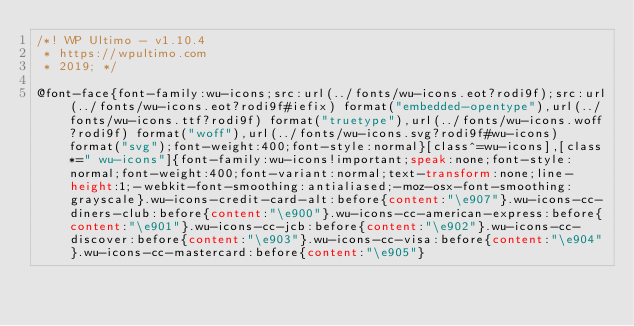Convert code to text. <code><loc_0><loc_0><loc_500><loc_500><_CSS_>/*! WP Ultimo - v1.10.4
 * https://wpultimo.com
 * 2019; */

@font-face{font-family:wu-icons;src:url(../fonts/wu-icons.eot?rodi9f);src:url(../fonts/wu-icons.eot?rodi9f#iefix) format("embedded-opentype"),url(../fonts/wu-icons.ttf?rodi9f) format("truetype"),url(../fonts/wu-icons.woff?rodi9f) format("woff"),url(../fonts/wu-icons.svg?rodi9f#wu-icons) format("svg");font-weight:400;font-style:normal}[class^=wu-icons],[class*=" wu-icons"]{font-family:wu-icons!important;speak:none;font-style:normal;font-weight:400;font-variant:normal;text-transform:none;line-height:1;-webkit-font-smoothing:antialiased;-moz-osx-font-smoothing:grayscale}.wu-icons-credit-card-alt:before{content:"\e907"}.wu-icons-cc-diners-club:before{content:"\e900"}.wu-icons-cc-american-express:before{content:"\e901"}.wu-icons-cc-jcb:before{content:"\e902"}.wu-icons-cc-discover:before{content:"\e903"}.wu-icons-cc-visa:before{content:"\e904"}.wu-icons-cc-mastercard:before{content:"\e905"}</code> 